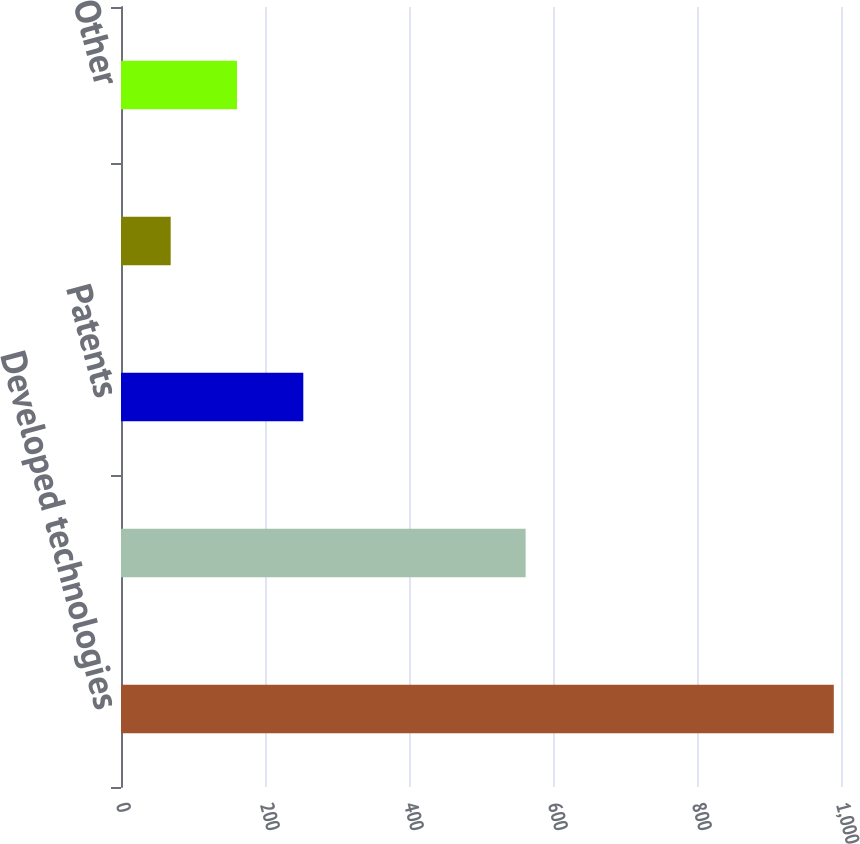Convert chart. <chart><loc_0><loc_0><loc_500><loc_500><bar_chart><fcel>Developed technologies<fcel>Customer relationships<fcel>Patents<fcel>Trademarks<fcel>Other<nl><fcel>990<fcel>562<fcel>253.2<fcel>69<fcel>161.1<nl></chart> 